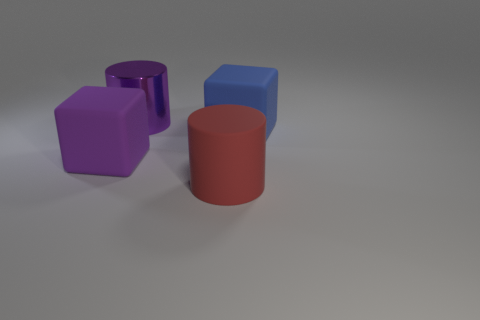Add 1 purple objects. How many objects exist? 5 Subtract 0 cyan cylinders. How many objects are left? 4 Subtract all large rubber cylinders. Subtract all big cylinders. How many objects are left? 1 Add 1 purple rubber things. How many purple rubber things are left? 2 Add 3 large shiny things. How many large shiny things exist? 4 